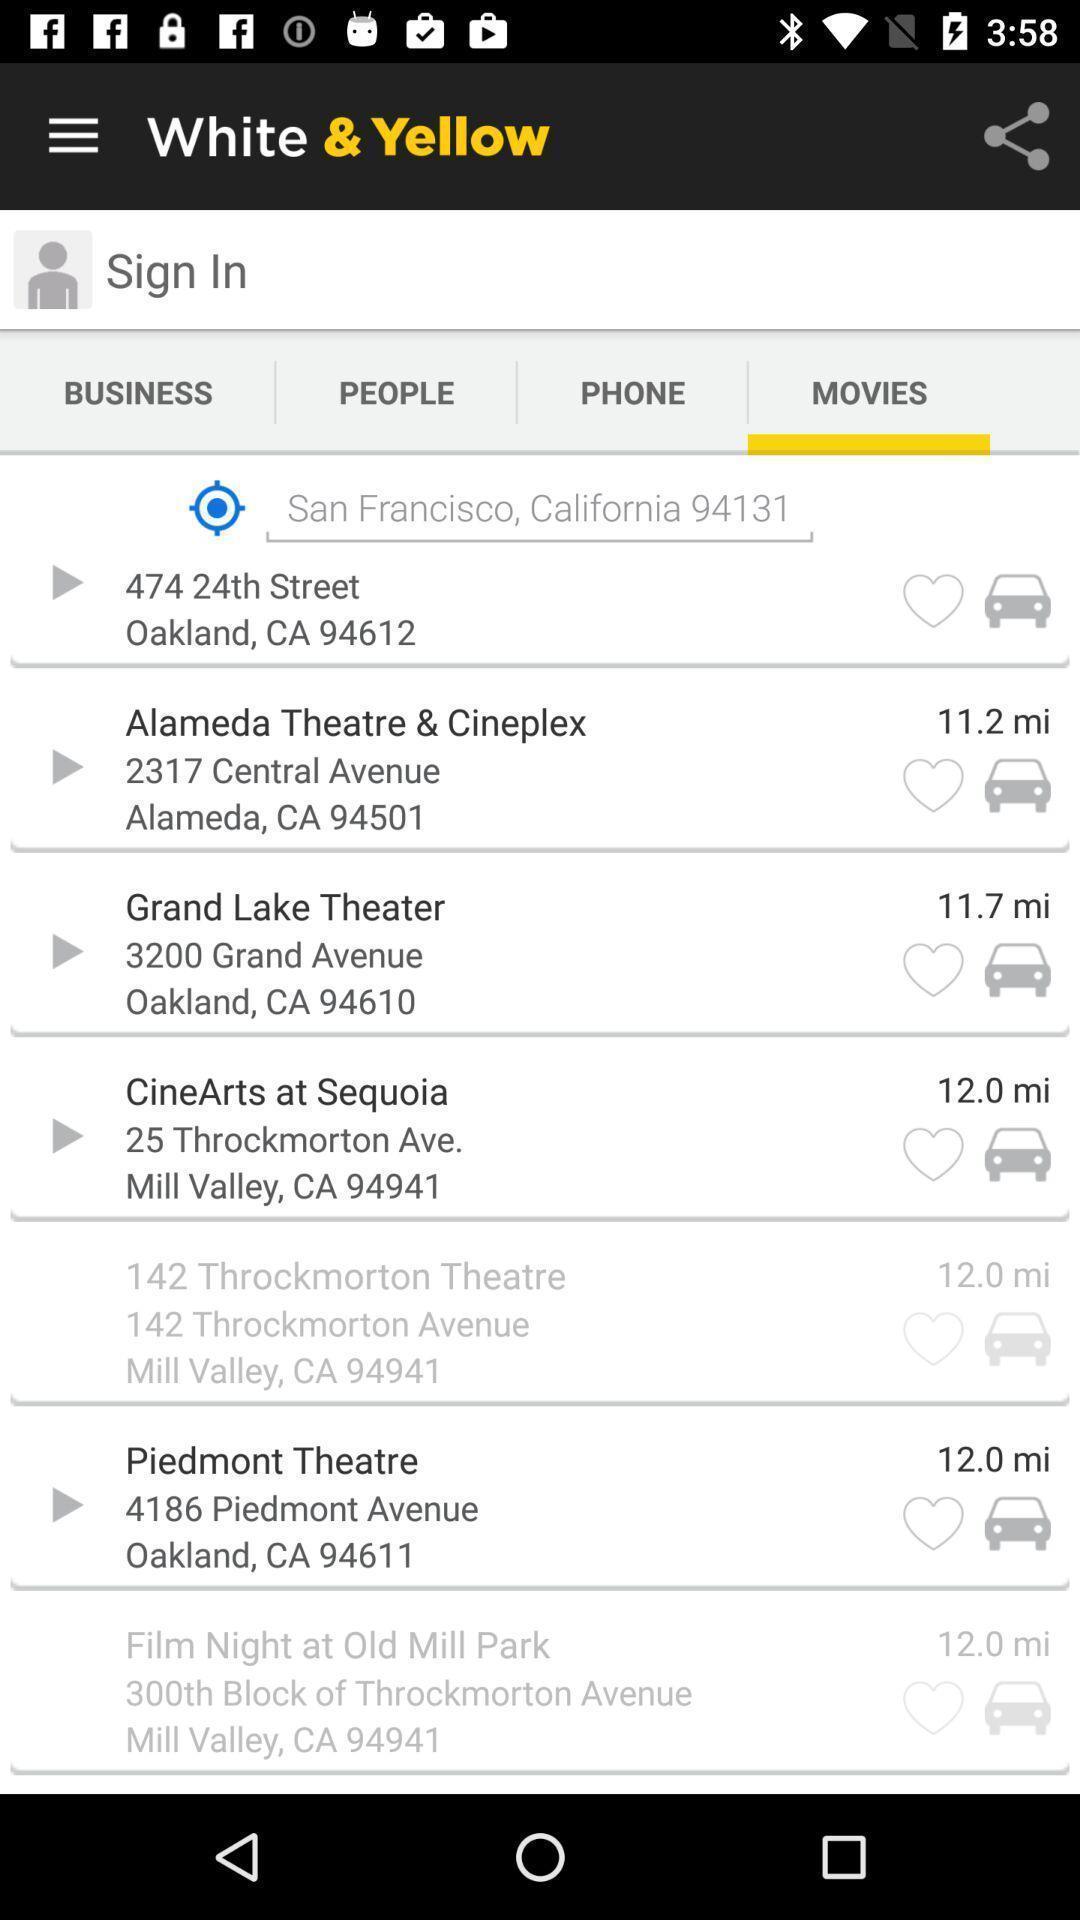Explain the elements present in this screenshot. Screen showing the list of trips. 